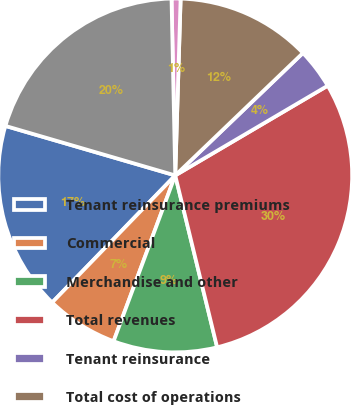Convert chart to OTSL. <chart><loc_0><loc_0><loc_500><loc_500><pie_chart><fcel>Tenant reinsurance premiums<fcel>Commercial<fcel>Merchandise and other<fcel>Total revenues<fcel>Tenant reinsurance<fcel>Total cost of operations<fcel>Depreciation ± commercial<fcel>Total ancillary net income<nl><fcel>17.27%<fcel>6.58%<fcel>9.47%<fcel>29.66%<fcel>3.7%<fcel>12.35%<fcel>0.82%<fcel>20.15%<nl></chart> 